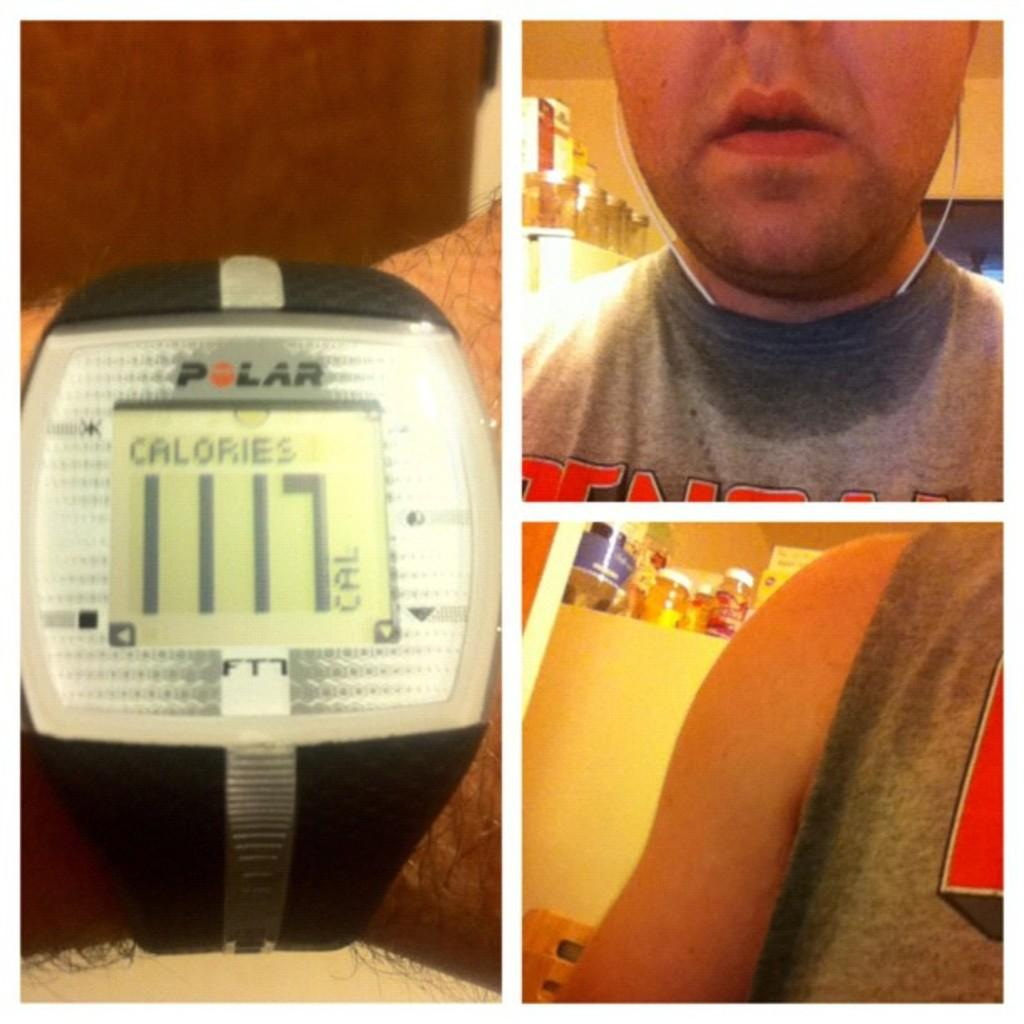Provide a one-sentence caption for the provided image. A watch shows 1117 calories on the digital screen. 